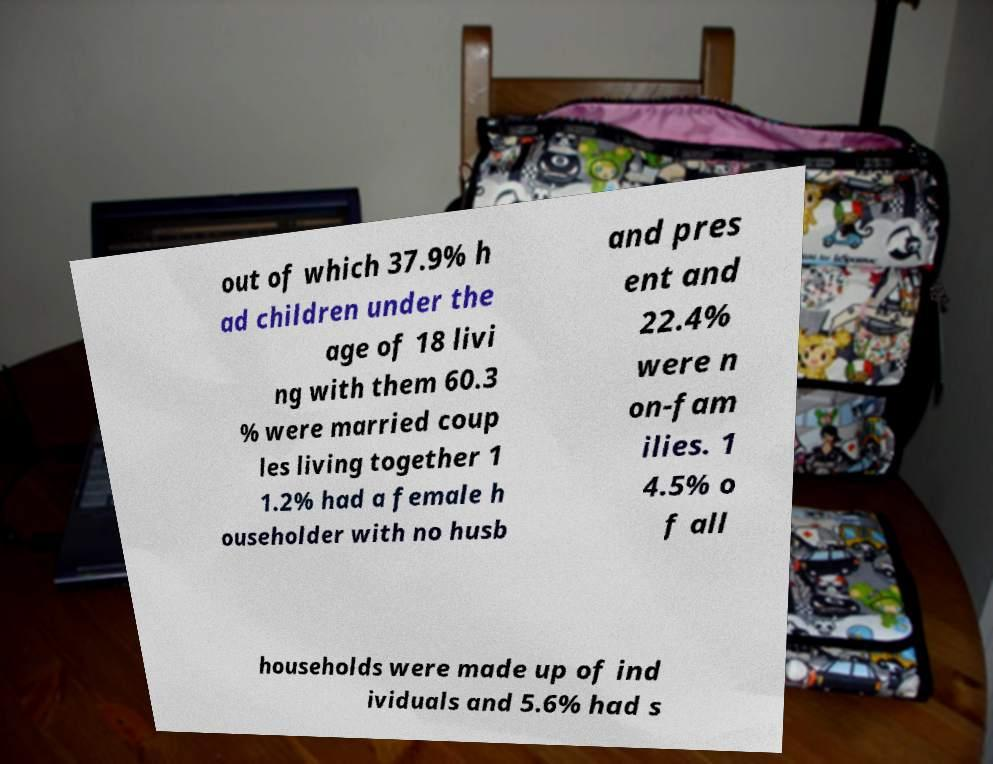Could you extract and type out the text from this image? out of which 37.9% h ad children under the age of 18 livi ng with them 60.3 % were married coup les living together 1 1.2% had a female h ouseholder with no husb and pres ent and 22.4% were n on-fam ilies. 1 4.5% o f all households were made up of ind ividuals and 5.6% had s 